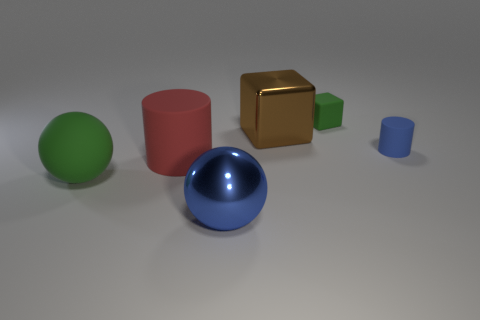How many green matte objects are left of the blue shiny thing?
Keep it short and to the point. 1. What number of brown objects are big matte blocks or big matte spheres?
Keep it short and to the point. 0. There is a block that is the same size as the red rubber thing; what is its material?
Provide a short and direct response. Metal. The thing that is behind the large green ball and to the left of the big brown metal block has what shape?
Give a very brief answer. Cylinder. What is the color of the other shiny thing that is the same size as the brown thing?
Your answer should be very brief. Blue. Do the green object right of the brown metallic thing and the cylinder that is to the right of the big blue shiny object have the same size?
Keep it short and to the point. Yes. There is a green object that is right of the blue thing in front of the cylinder to the right of the big blue metal thing; what is its size?
Offer a very short reply. Small. What shape is the green thing that is in front of the green object that is right of the large red object?
Provide a short and direct response. Sphere. There is a ball in front of the large green ball; does it have the same color as the small cylinder?
Provide a short and direct response. Yes. There is a large object that is right of the big cylinder and behind the large blue ball; what color is it?
Keep it short and to the point. Brown. 